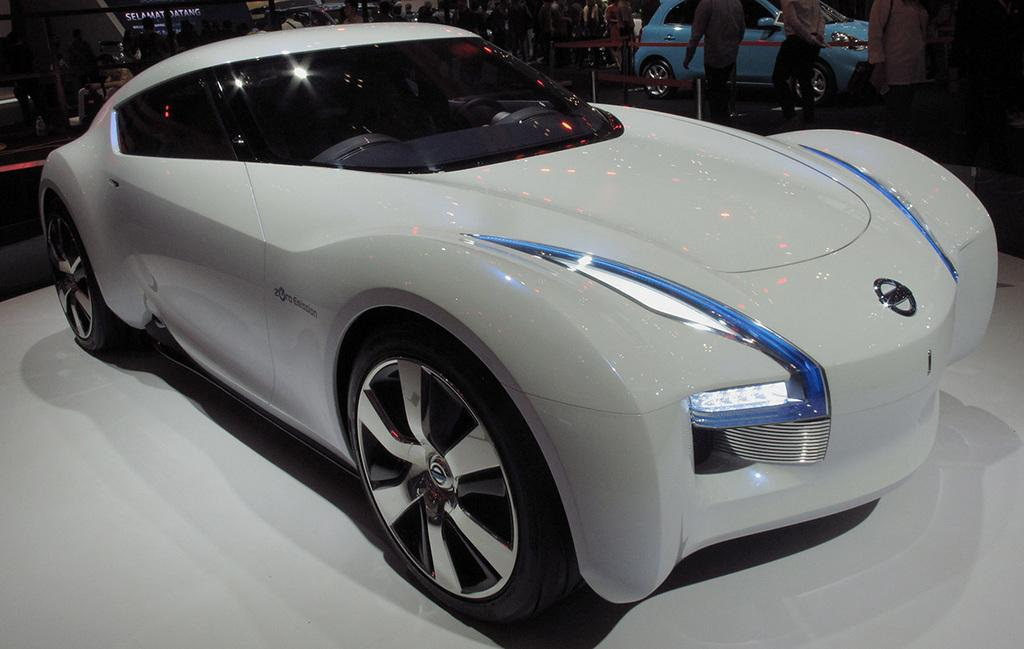What can be seen in the image involving a gathering of individuals? There is a group of people in the image. What else is present in the image besides the group of people? There are parked vehicles, poles, and ribbons in the image. Can you describe the background of the image? The sky is visible at the top of the image. What type of reward is being handed out to the people in the image? There is no reward being handed out in the image; it only shows a group of people, parked vehicles, poles, ribbons, and the sky. Can you see any ball being played with in the image? There is no ball present in the image. 